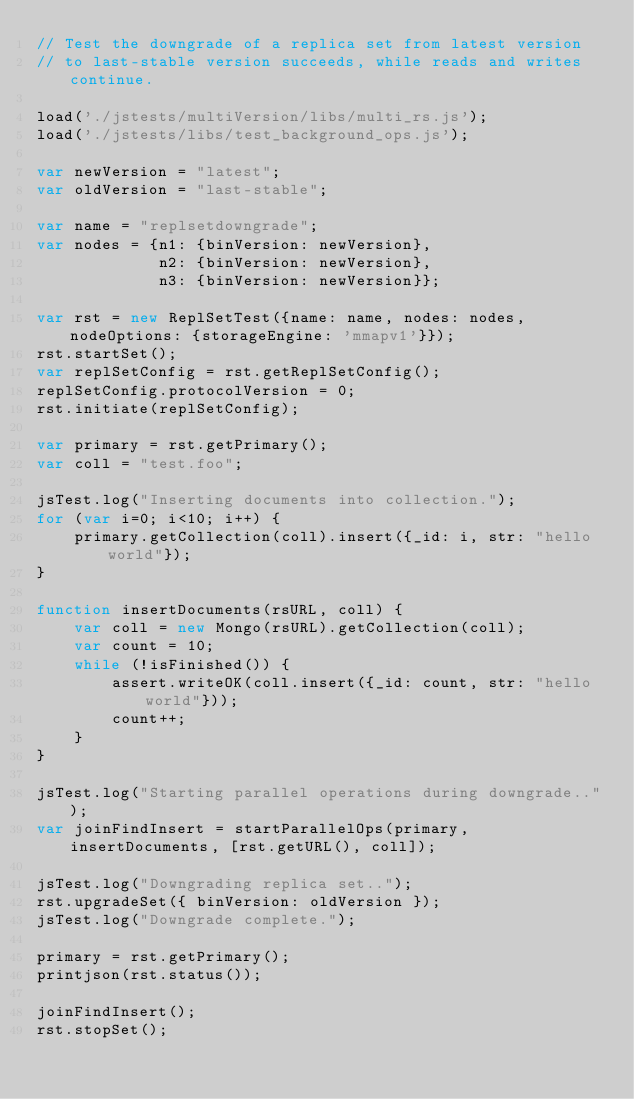<code> <loc_0><loc_0><loc_500><loc_500><_JavaScript_>// Test the downgrade of a replica set from latest version
// to last-stable version succeeds, while reads and writes continue.

load('./jstests/multiVersion/libs/multi_rs.js');
load('./jstests/libs/test_background_ops.js');

var newVersion = "latest";
var oldVersion = "last-stable";

var name = "replsetdowngrade";
var nodes = {n1: {binVersion: newVersion},
             n2: {binVersion: newVersion},
             n3: {binVersion: newVersion}};

var rst = new ReplSetTest({name: name, nodes: nodes, nodeOptions: {storageEngine: 'mmapv1'}});
rst.startSet();
var replSetConfig = rst.getReplSetConfig();
replSetConfig.protocolVersion = 0;
rst.initiate(replSetConfig);

var primary = rst.getPrimary();
var coll = "test.foo";

jsTest.log("Inserting documents into collection.");
for (var i=0; i<10; i++) {
    primary.getCollection(coll).insert({_id: i, str: "hello world"});
}

function insertDocuments(rsURL, coll) {
    var coll = new Mongo(rsURL).getCollection(coll);
    var count = 10;
    while (!isFinished()) {
        assert.writeOK(coll.insert({_id: count, str: "hello world"}));
        count++;
    }
}

jsTest.log("Starting parallel operations during downgrade..");
var joinFindInsert = startParallelOps(primary, insertDocuments, [rst.getURL(), coll]);

jsTest.log("Downgrading replica set..");
rst.upgradeSet({ binVersion: oldVersion });
jsTest.log("Downgrade complete.");

primary = rst.getPrimary();
printjson(rst.status());

joinFindInsert();
rst.stopSet();
</code> 